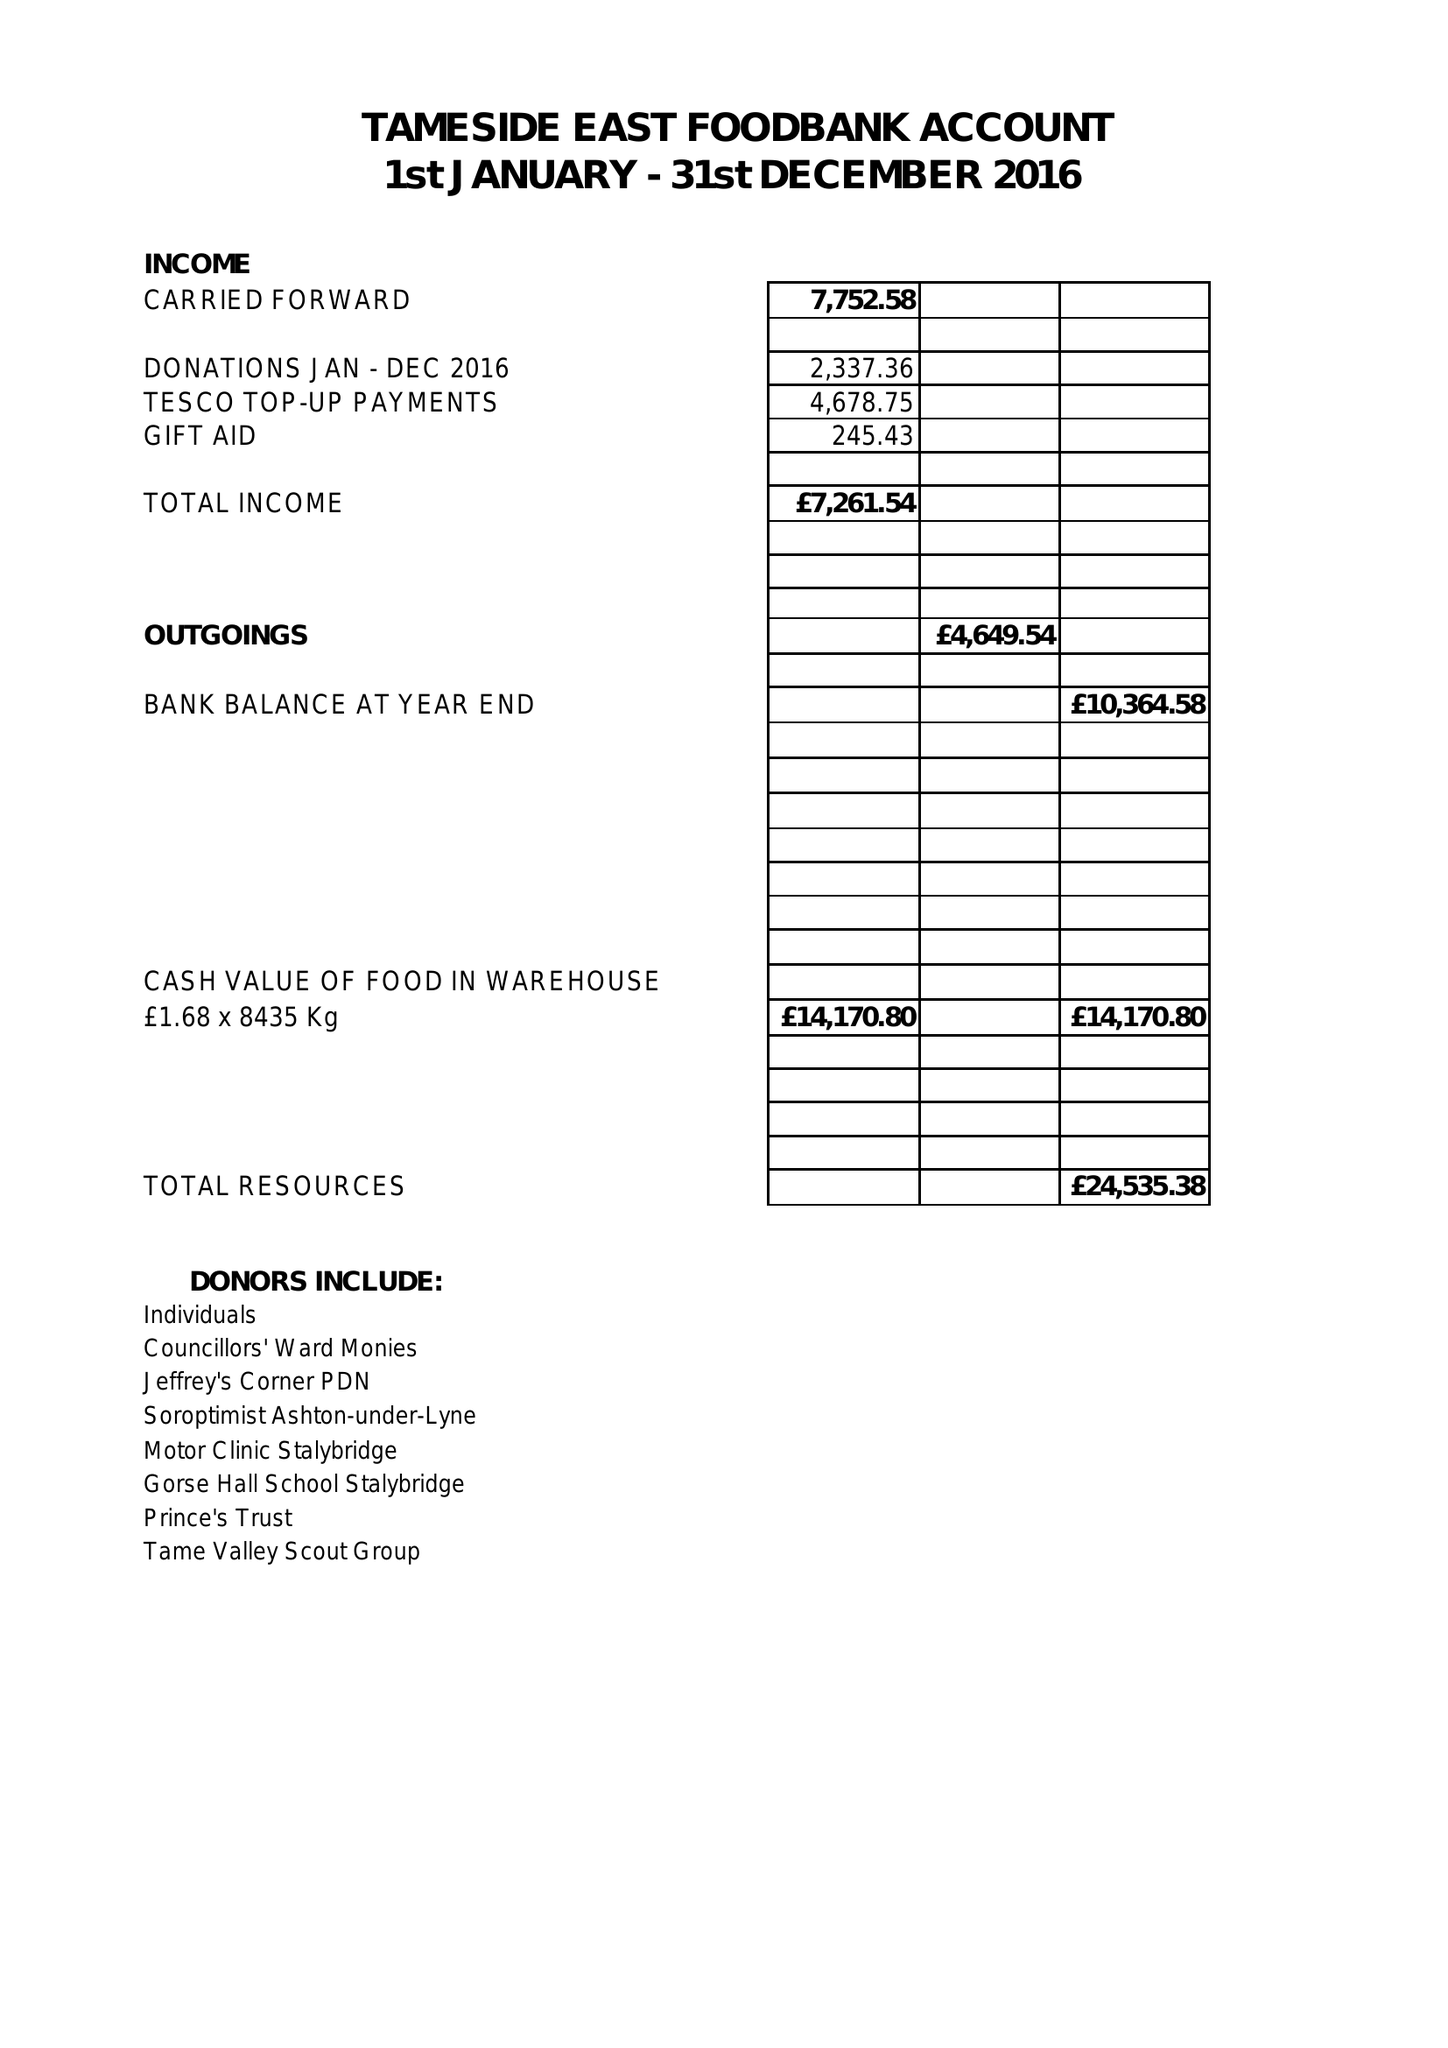What is the value for the address__street_line?
Answer the question using a single word or phrase. 19 CORPORATION STREET 